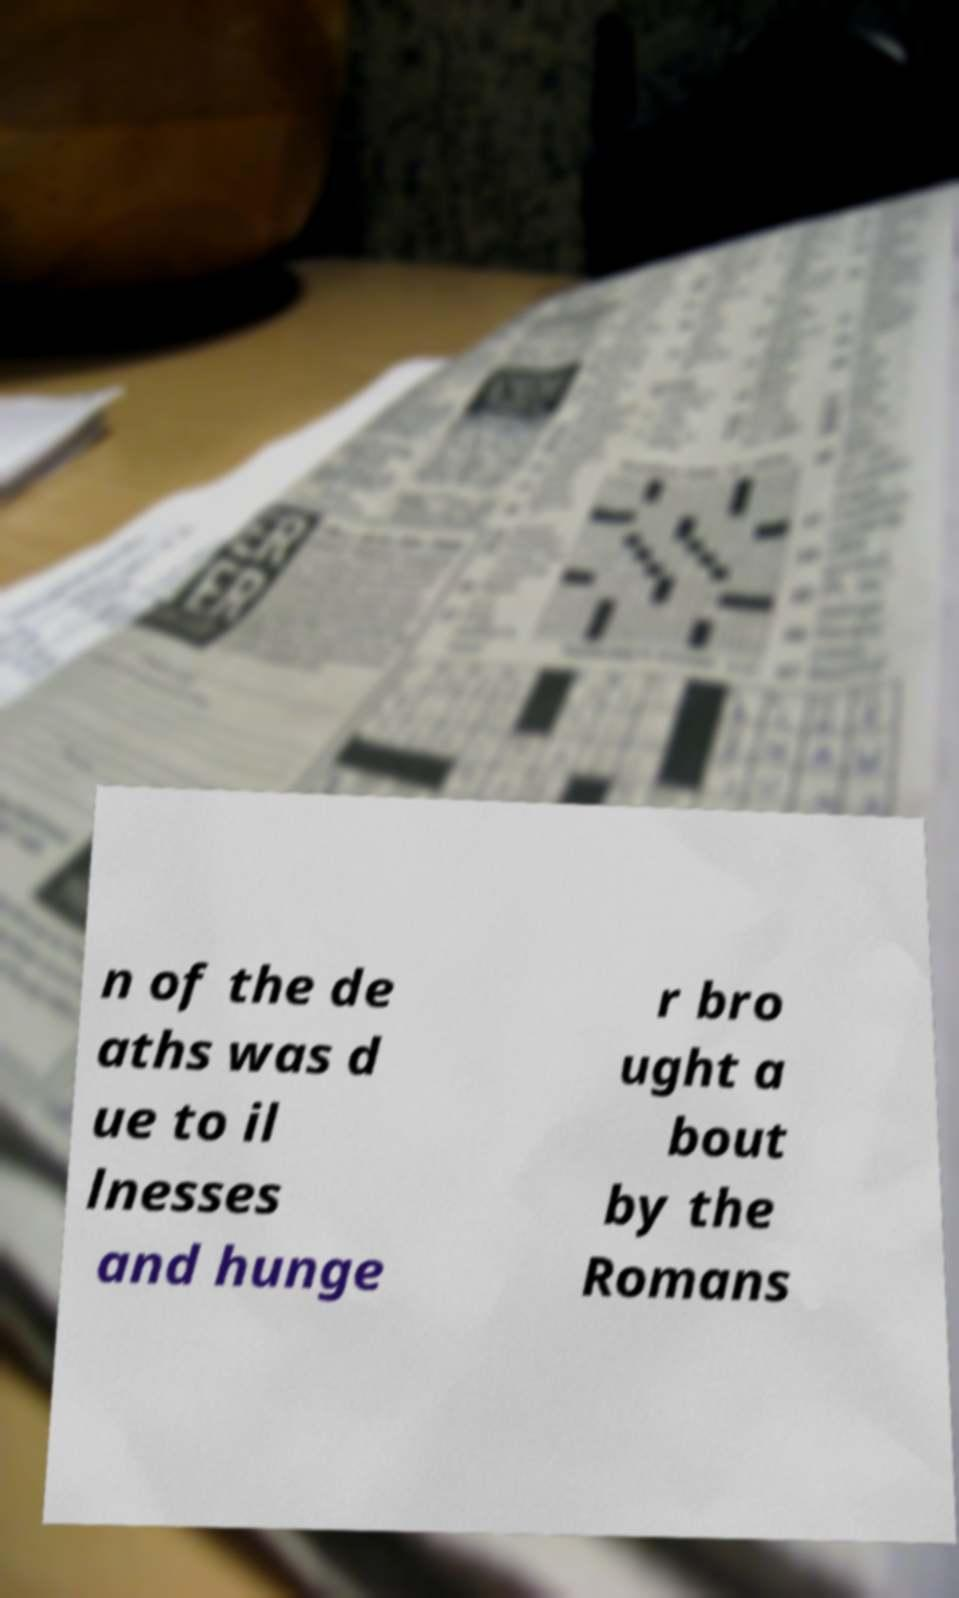There's text embedded in this image that I need extracted. Can you transcribe it verbatim? n of the de aths was d ue to il lnesses and hunge r bro ught a bout by the Romans 